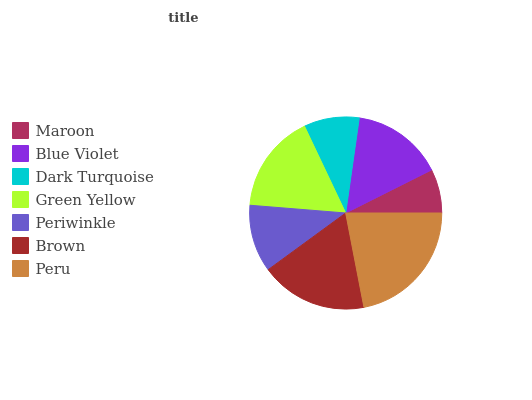Is Maroon the minimum?
Answer yes or no. Yes. Is Peru the maximum?
Answer yes or no. Yes. Is Blue Violet the minimum?
Answer yes or no. No. Is Blue Violet the maximum?
Answer yes or no. No. Is Blue Violet greater than Maroon?
Answer yes or no. Yes. Is Maroon less than Blue Violet?
Answer yes or no. Yes. Is Maroon greater than Blue Violet?
Answer yes or no. No. Is Blue Violet less than Maroon?
Answer yes or no. No. Is Blue Violet the high median?
Answer yes or no. Yes. Is Blue Violet the low median?
Answer yes or no. Yes. Is Peru the high median?
Answer yes or no. No. Is Peru the low median?
Answer yes or no. No. 